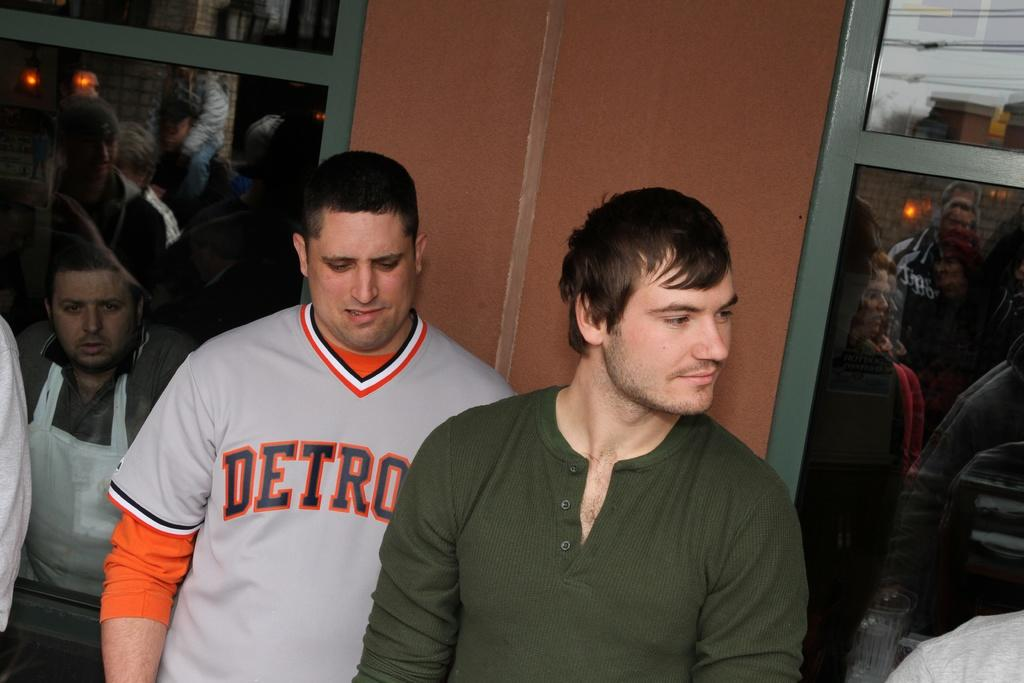<image>
Give a short and clear explanation of the subsequent image. Two men, one is wearing a jersey displaying the city of Detroit. 